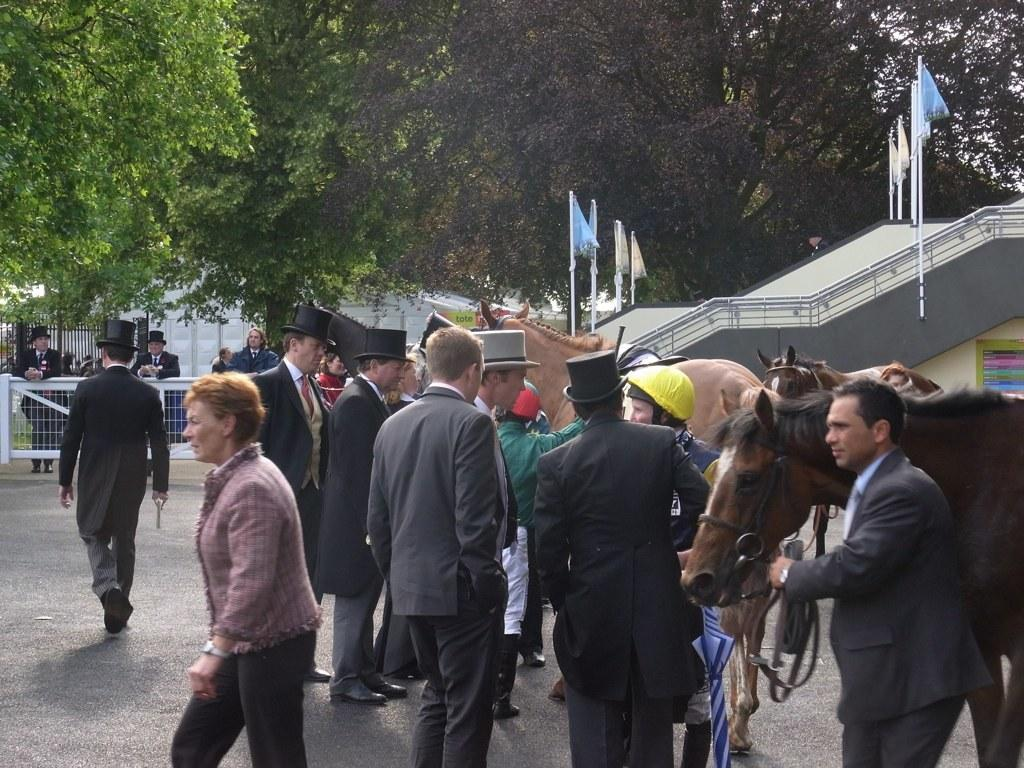Who or what can be seen in the image? There are people and horses in the image. What is visible in the background of the image? There are flags and trees in the background of the image. What month is being celebrated by the organization in the image? There is no organization or specific month mentioned in the image, so it cannot be determined. 